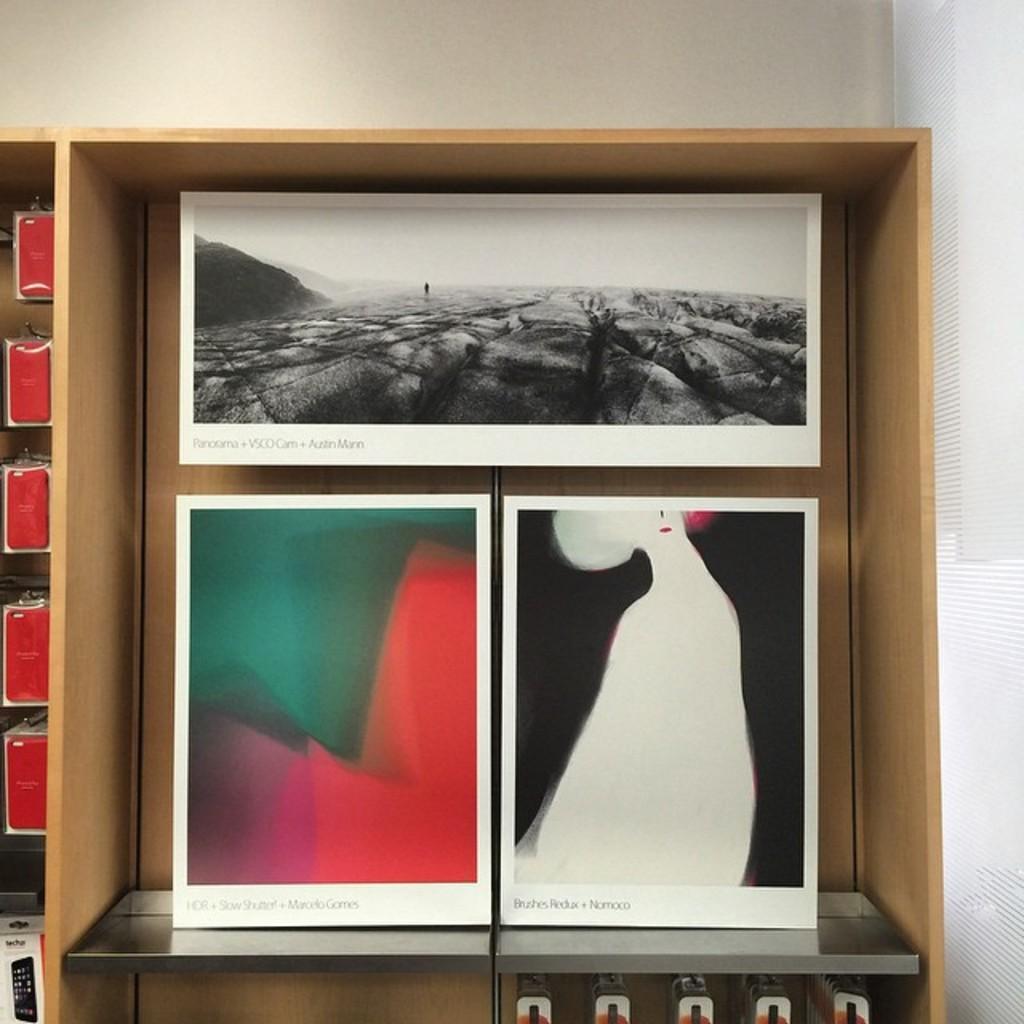In one or two sentences, can you explain what this image depicts? This picture seems to be clicked inside the room. In the foreground we can see the wooden object and we can see the white color objects which seems to be the posters containing the pictures of some items. In the background we can see the wall and some other items. 